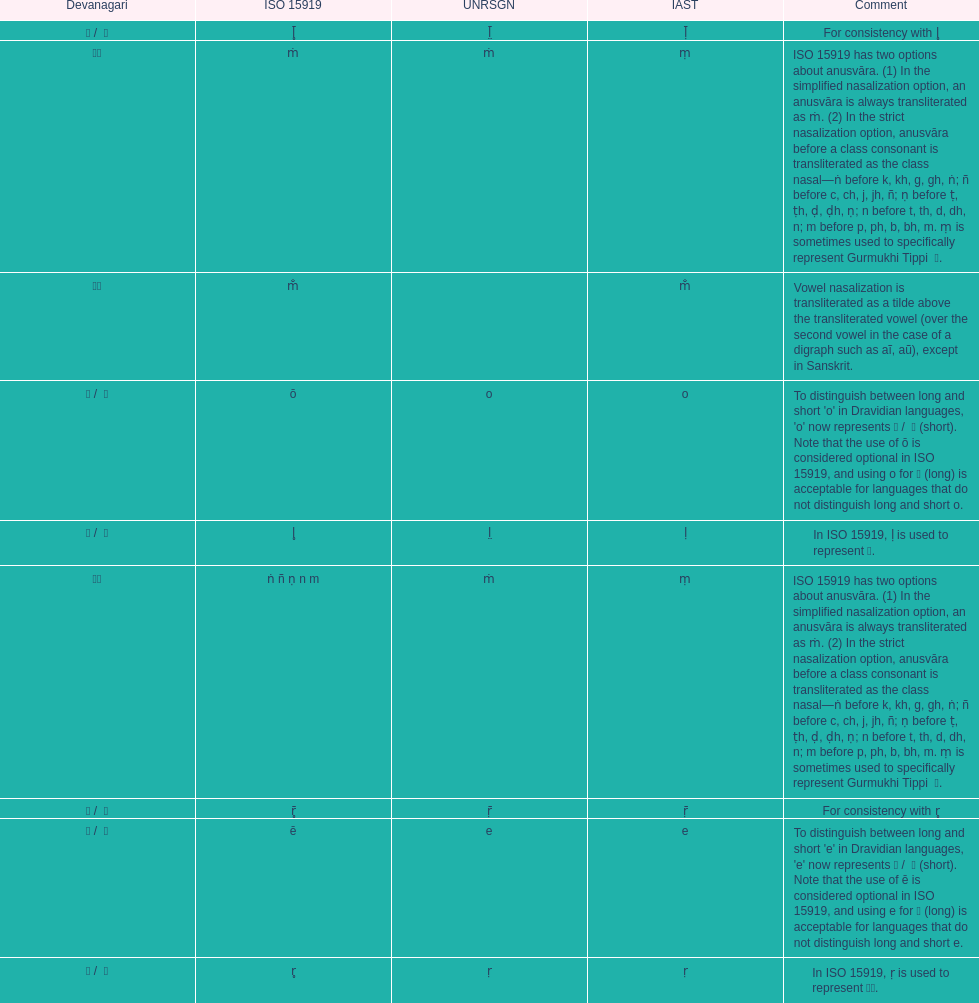What iast is listed before the o? E. 